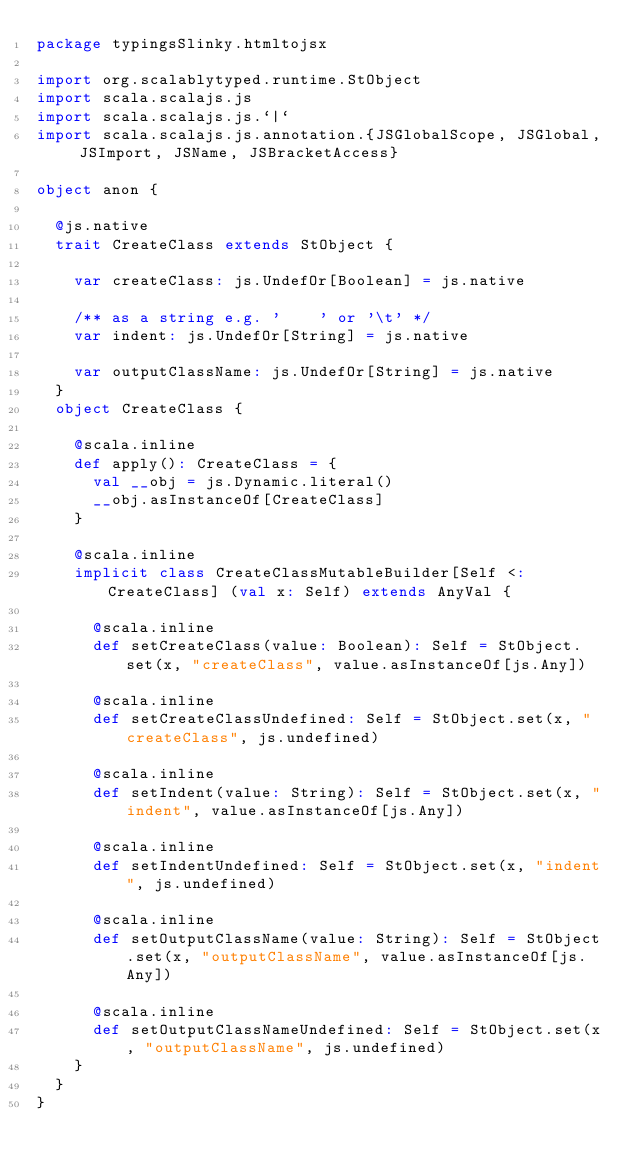<code> <loc_0><loc_0><loc_500><loc_500><_Scala_>package typingsSlinky.htmltojsx

import org.scalablytyped.runtime.StObject
import scala.scalajs.js
import scala.scalajs.js.`|`
import scala.scalajs.js.annotation.{JSGlobalScope, JSGlobal, JSImport, JSName, JSBracketAccess}

object anon {
  
  @js.native
  trait CreateClass extends StObject {
    
    var createClass: js.UndefOr[Boolean] = js.native
    
    /** as a string e.g. '    ' or '\t' */
    var indent: js.UndefOr[String] = js.native
    
    var outputClassName: js.UndefOr[String] = js.native
  }
  object CreateClass {
    
    @scala.inline
    def apply(): CreateClass = {
      val __obj = js.Dynamic.literal()
      __obj.asInstanceOf[CreateClass]
    }
    
    @scala.inline
    implicit class CreateClassMutableBuilder[Self <: CreateClass] (val x: Self) extends AnyVal {
      
      @scala.inline
      def setCreateClass(value: Boolean): Self = StObject.set(x, "createClass", value.asInstanceOf[js.Any])
      
      @scala.inline
      def setCreateClassUndefined: Self = StObject.set(x, "createClass", js.undefined)
      
      @scala.inline
      def setIndent(value: String): Self = StObject.set(x, "indent", value.asInstanceOf[js.Any])
      
      @scala.inline
      def setIndentUndefined: Self = StObject.set(x, "indent", js.undefined)
      
      @scala.inline
      def setOutputClassName(value: String): Self = StObject.set(x, "outputClassName", value.asInstanceOf[js.Any])
      
      @scala.inline
      def setOutputClassNameUndefined: Self = StObject.set(x, "outputClassName", js.undefined)
    }
  }
}
</code> 